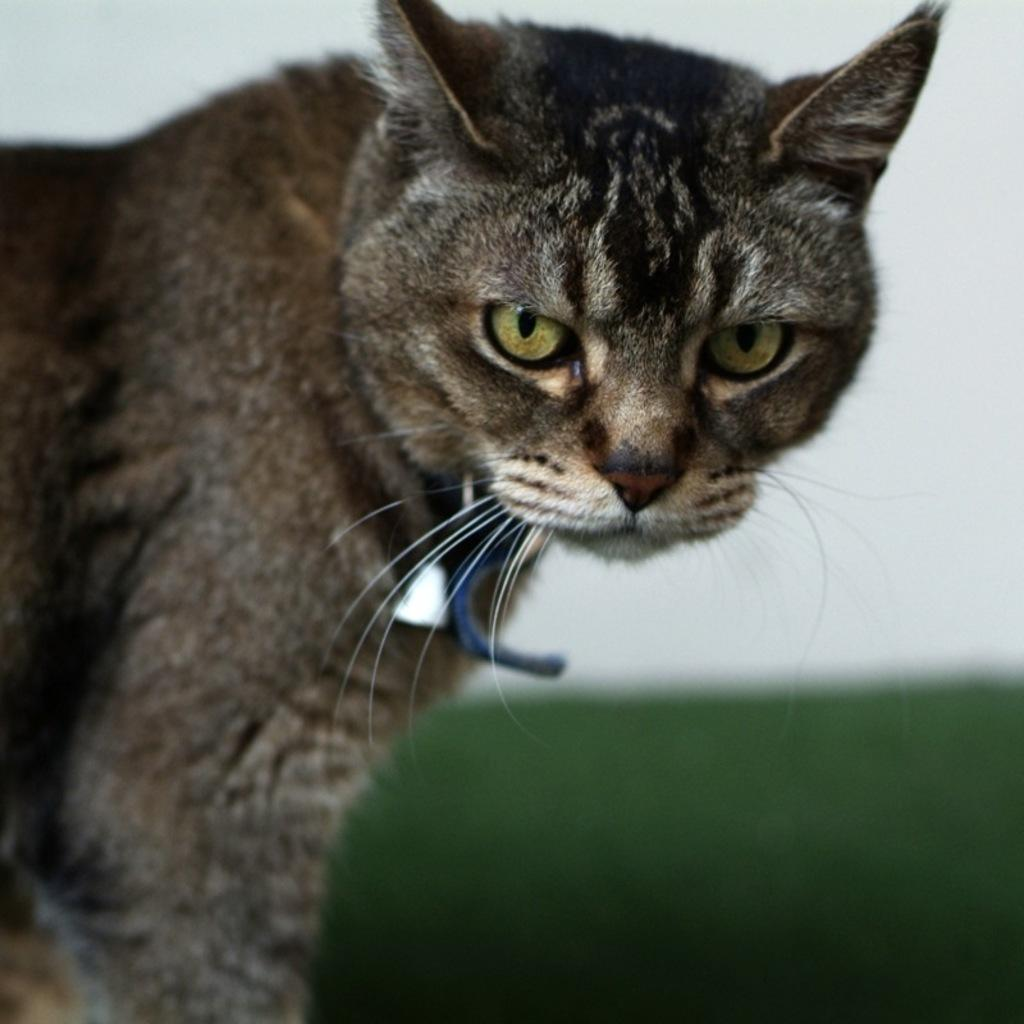What type of animal is in the picture? There is a cat in the picture. What is attached to the cat's neck? The cat has a rope around its neck. What can be seen in the background of the picture? There is a wall visible in the background of the picture. What type of string is the cat playing with in the image? There is no string present in the image; the cat has a rope around its neck. Where is the seat located in the image? There is no seat present in the image. 